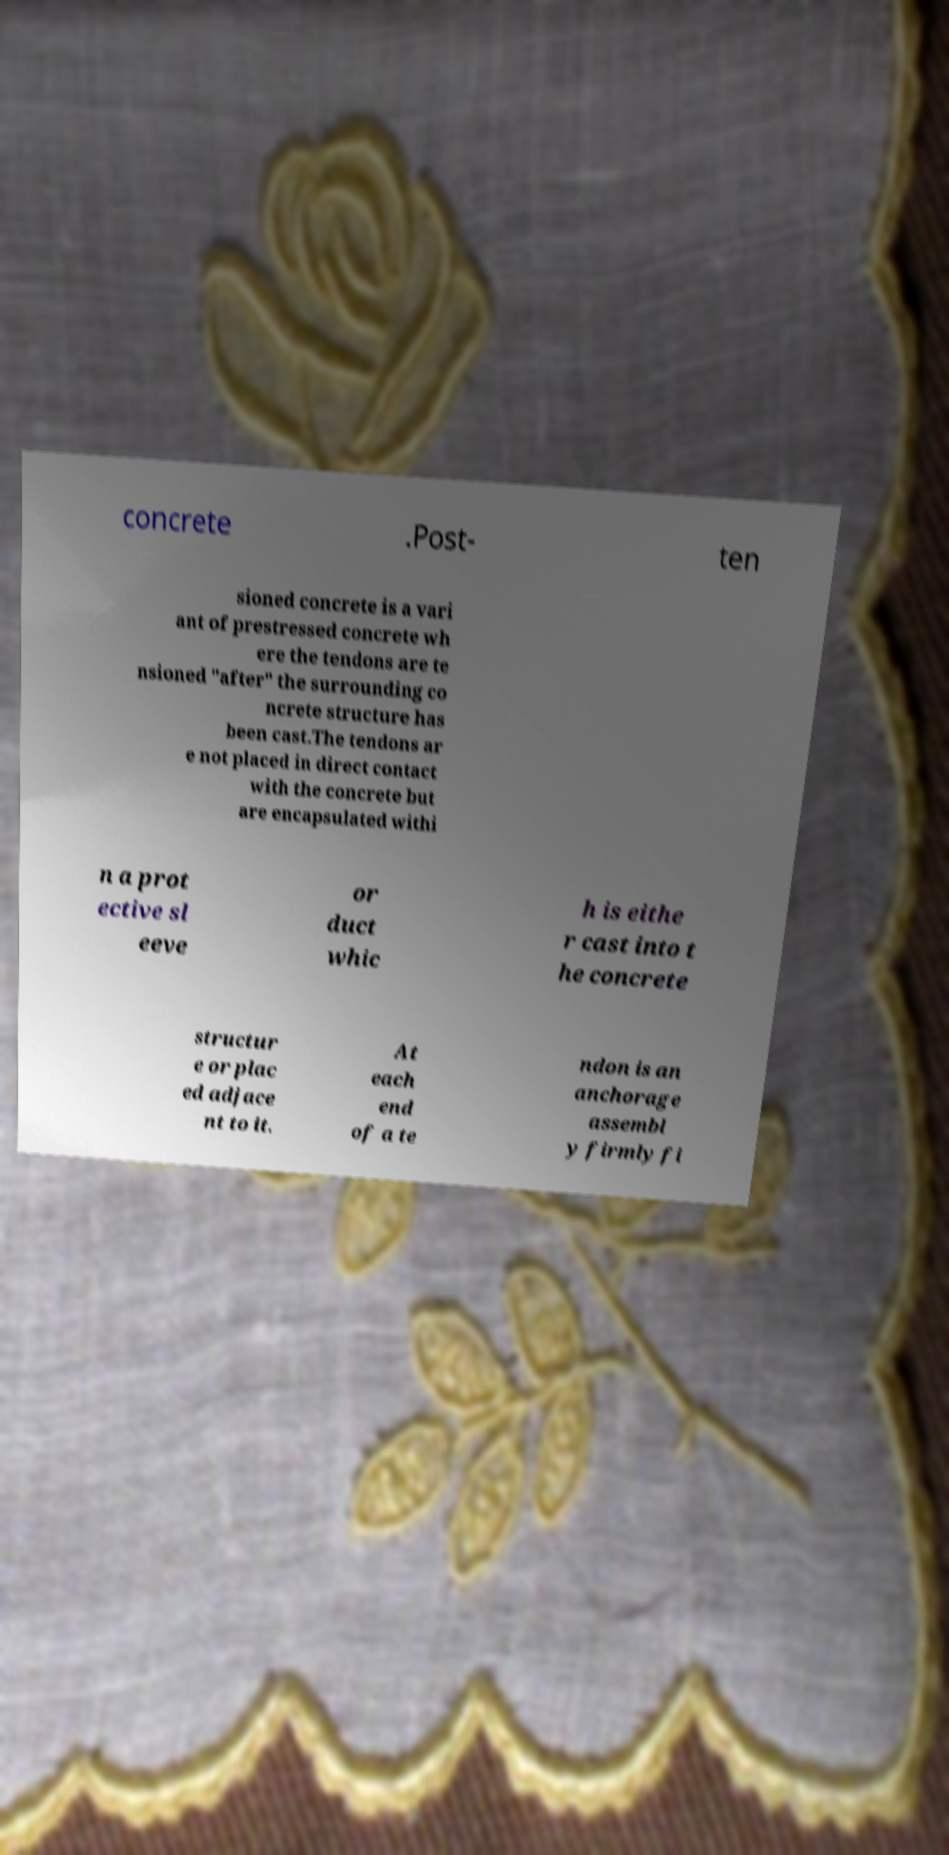There's text embedded in this image that I need extracted. Can you transcribe it verbatim? concrete .Post- ten sioned concrete is a vari ant of prestressed concrete wh ere the tendons are te nsioned "after" the surrounding co ncrete structure has been cast.The tendons ar e not placed in direct contact with the concrete but are encapsulated withi n a prot ective sl eeve or duct whic h is eithe r cast into t he concrete structur e or plac ed adjace nt to it. At each end of a te ndon is an anchorage assembl y firmly fi 